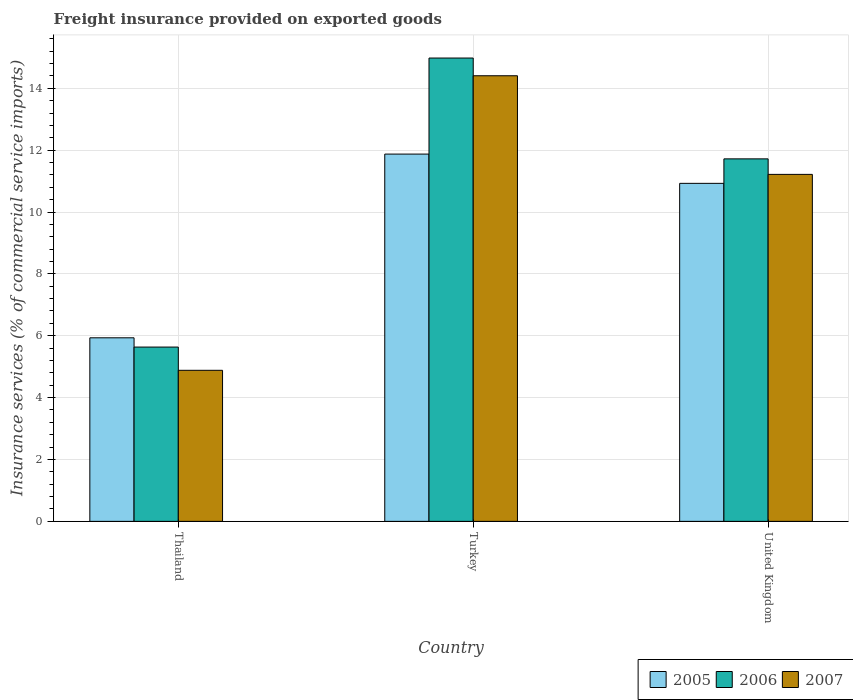How many different coloured bars are there?
Make the answer very short. 3. How many groups of bars are there?
Offer a very short reply. 3. How many bars are there on the 3rd tick from the left?
Your response must be concise. 3. What is the label of the 1st group of bars from the left?
Your answer should be very brief. Thailand. In how many cases, is the number of bars for a given country not equal to the number of legend labels?
Make the answer very short. 0. What is the freight insurance provided on exported goods in 2007 in United Kingdom?
Your answer should be very brief. 11.22. Across all countries, what is the maximum freight insurance provided on exported goods in 2005?
Your answer should be compact. 11.87. Across all countries, what is the minimum freight insurance provided on exported goods in 2005?
Your response must be concise. 5.93. In which country was the freight insurance provided on exported goods in 2005 minimum?
Give a very brief answer. Thailand. What is the total freight insurance provided on exported goods in 2007 in the graph?
Keep it short and to the point. 30.5. What is the difference between the freight insurance provided on exported goods in 2007 in Thailand and that in United Kingdom?
Keep it short and to the point. -6.33. What is the difference between the freight insurance provided on exported goods in 2005 in Thailand and the freight insurance provided on exported goods in 2007 in Turkey?
Offer a terse response. -8.47. What is the average freight insurance provided on exported goods in 2006 per country?
Offer a very short reply. 10.78. What is the difference between the freight insurance provided on exported goods of/in 2007 and freight insurance provided on exported goods of/in 2005 in Thailand?
Give a very brief answer. -1.05. What is the ratio of the freight insurance provided on exported goods in 2005 in Thailand to that in United Kingdom?
Provide a short and direct response. 0.54. Is the freight insurance provided on exported goods in 2006 in Thailand less than that in United Kingdom?
Offer a very short reply. Yes. Is the difference between the freight insurance provided on exported goods in 2007 in Turkey and United Kingdom greater than the difference between the freight insurance provided on exported goods in 2005 in Turkey and United Kingdom?
Your answer should be compact. Yes. What is the difference between the highest and the second highest freight insurance provided on exported goods in 2006?
Provide a short and direct response. 6.08. What is the difference between the highest and the lowest freight insurance provided on exported goods in 2006?
Your response must be concise. 9.34. In how many countries, is the freight insurance provided on exported goods in 2005 greater than the average freight insurance provided on exported goods in 2005 taken over all countries?
Keep it short and to the point. 2. Is the sum of the freight insurance provided on exported goods in 2005 in Thailand and Turkey greater than the maximum freight insurance provided on exported goods in 2006 across all countries?
Your response must be concise. Yes. What does the 2nd bar from the left in Turkey represents?
Your answer should be very brief. 2006. What does the 3rd bar from the right in Turkey represents?
Give a very brief answer. 2005. Are all the bars in the graph horizontal?
Give a very brief answer. No. How many countries are there in the graph?
Keep it short and to the point. 3. What is the difference between two consecutive major ticks on the Y-axis?
Make the answer very short. 2. Are the values on the major ticks of Y-axis written in scientific E-notation?
Your response must be concise. No. Where does the legend appear in the graph?
Make the answer very short. Bottom right. How many legend labels are there?
Give a very brief answer. 3. How are the legend labels stacked?
Your answer should be very brief. Horizontal. What is the title of the graph?
Provide a succinct answer. Freight insurance provided on exported goods. What is the label or title of the X-axis?
Your answer should be very brief. Country. What is the label or title of the Y-axis?
Ensure brevity in your answer.  Insurance services (% of commercial service imports). What is the Insurance services (% of commercial service imports) in 2005 in Thailand?
Provide a short and direct response. 5.93. What is the Insurance services (% of commercial service imports) of 2006 in Thailand?
Your response must be concise. 5.63. What is the Insurance services (% of commercial service imports) of 2007 in Thailand?
Offer a terse response. 4.88. What is the Insurance services (% of commercial service imports) in 2005 in Turkey?
Keep it short and to the point. 11.87. What is the Insurance services (% of commercial service imports) of 2006 in Turkey?
Your response must be concise. 14.98. What is the Insurance services (% of commercial service imports) in 2007 in Turkey?
Provide a short and direct response. 14.4. What is the Insurance services (% of commercial service imports) of 2005 in United Kingdom?
Offer a terse response. 10.93. What is the Insurance services (% of commercial service imports) of 2006 in United Kingdom?
Keep it short and to the point. 11.72. What is the Insurance services (% of commercial service imports) of 2007 in United Kingdom?
Make the answer very short. 11.22. Across all countries, what is the maximum Insurance services (% of commercial service imports) in 2005?
Provide a short and direct response. 11.87. Across all countries, what is the maximum Insurance services (% of commercial service imports) of 2006?
Ensure brevity in your answer.  14.98. Across all countries, what is the maximum Insurance services (% of commercial service imports) in 2007?
Your answer should be very brief. 14.4. Across all countries, what is the minimum Insurance services (% of commercial service imports) of 2005?
Provide a short and direct response. 5.93. Across all countries, what is the minimum Insurance services (% of commercial service imports) in 2006?
Keep it short and to the point. 5.63. Across all countries, what is the minimum Insurance services (% of commercial service imports) of 2007?
Your response must be concise. 4.88. What is the total Insurance services (% of commercial service imports) of 2005 in the graph?
Keep it short and to the point. 28.73. What is the total Insurance services (% of commercial service imports) of 2006 in the graph?
Offer a very short reply. 32.33. What is the total Insurance services (% of commercial service imports) of 2007 in the graph?
Offer a very short reply. 30.5. What is the difference between the Insurance services (% of commercial service imports) in 2005 in Thailand and that in Turkey?
Your answer should be compact. -5.94. What is the difference between the Insurance services (% of commercial service imports) in 2006 in Thailand and that in Turkey?
Your response must be concise. -9.34. What is the difference between the Insurance services (% of commercial service imports) of 2007 in Thailand and that in Turkey?
Provide a short and direct response. -9.52. What is the difference between the Insurance services (% of commercial service imports) of 2005 in Thailand and that in United Kingdom?
Provide a short and direct response. -4.99. What is the difference between the Insurance services (% of commercial service imports) in 2006 in Thailand and that in United Kingdom?
Give a very brief answer. -6.08. What is the difference between the Insurance services (% of commercial service imports) of 2007 in Thailand and that in United Kingdom?
Provide a succinct answer. -6.33. What is the difference between the Insurance services (% of commercial service imports) of 2005 in Turkey and that in United Kingdom?
Offer a terse response. 0.95. What is the difference between the Insurance services (% of commercial service imports) of 2006 in Turkey and that in United Kingdom?
Provide a short and direct response. 3.26. What is the difference between the Insurance services (% of commercial service imports) of 2007 in Turkey and that in United Kingdom?
Offer a very short reply. 3.19. What is the difference between the Insurance services (% of commercial service imports) in 2005 in Thailand and the Insurance services (% of commercial service imports) in 2006 in Turkey?
Provide a short and direct response. -9.04. What is the difference between the Insurance services (% of commercial service imports) of 2005 in Thailand and the Insurance services (% of commercial service imports) of 2007 in Turkey?
Offer a very short reply. -8.47. What is the difference between the Insurance services (% of commercial service imports) in 2006 in Thailand and the Insurance services (% of commercial service imports) in 2007 in Turkey?
Give a very brief answer. -8.77. What is the difference between the Insurance services (% of commercial service imports) in 2005 in Thailand and the Insurance services (% of commercial service imports) in 2006 in United Kingdom?
Make the answer very short. -5.78. What is the difference between the Insurance services (% of commercial service imports) of 2005 in Thailand and the Insurance services (% of commercial service imports) of 2007 in United Kingdom?
Your response must be concise. -5.28. What is the difference between the Insurance services (% of commercial service imports) in 2006 in Thailand and the Insurance services (% of commercial service imports) in 2007 in United Kingdom?
Your answer should be compact. -5.58. What is the difference between the Insurance services (% of commercial service imports) in 2005 in Turkey and the Insurance services (% of commercial service imports) in 2006 in United Kingdom?
Provide a succinct answer. 0.15. What is the difference between the Insurance services (% of commercial service imports) of 2005 in Turkey and the Insurance services (% of commercial service imports) of 2007 in United Kingdom?
Ensure brevity in your answer.  0.66. What is the difference between the Insurance services (% of commercial service imports) in 2006 in Turkey and the Insurance services (% of commercial service imports) in 2007 in United Kingdom?
Provide a short and direct response. 3.76. What is the average Insurance services (% of commercial service imports) of 2005 per country?
Offer a very short reply. 9.58. What is the average Insurance services (% of commercial service imports) of 2006 per country?
Your answer should be compact. 10.78. What is the average Insurance services (% of commercial service imports) of 2007 per country?
Offer a terse response. 10.17. What is the difference between the Insurance services (% of commercial service imports) of 2005 and Insurance services (% of commercial service imports) of 2006 in Thailand?
Ensure brevity in your answer.  0.3. What is the difference between the Insurance services (% of commercial service imports) of 2005 and Insurance services (% of commercial service imports) of 2007 in Thailand?
Your response must be concise. 1.05. What is the difference between the Insurance services (% of commercial service imports) of 2006 and Insurance services (% of commercial service imports) of 2007 in Thailand?
Give a very brief answer. 0.75. What is the difference between the Insurance services (% of commercial service imports) of 2005 and Insurance services (% of commercial service imports) of 2006 in Turkey?
Ensure brevity in your answer.  -3.1. What is the difference between the Insurance services (% of commercial service imports) in 2005 and Insurance services (% of commercial service imports) in 2007 in Turkey?
Keep it short and to the point. -2.53. What is the difference between the Insurance services (% of commercial service imports) of 2006 and Insurance services (% of commercial service imports) of 2007 in Turkey?
Provide a succinct answer. 0.57. What is the difference between the Insurance services (% of commercial service imports) of 2005 and Insurance services (% of commercial service imports) of 2006 in United Kingdom?
Keep it short and to the point. -0.79. What is the difference between the Insurance services (% of commercial service imports) of 2005 and Insurance services (% of commercial service imports) of 2007 in United Kingdom?
Keep it short and to the point. -0.29. What is the difference between the Insurance services (% of commercial service imports) of 2006 and Insurance services (% of commercial service imports) of 2007 in United Kingdom?
Ensure brevity in your answer.  0.5. What is the ratio of the Insurance services (% of commercial service imports) of 2005 in Thailand to that in Turkey?
Keep it short and to the point. 0.5. What is the ratio of the Insurance services (% of commercial service imports) of 2006 in Thailand to that in Turkey?
Keep it short and to the point. 0.38. What is the ratio of the Insurance services (% of commercial service imports) in 2007 in Thailand to that in Turkey?
Offer a terse response. 0.34. What is the ratio of the Insurance services (% of commercial service imports) in 2005 in Thailand to that in United Kingdom?
Provide a short and direct response. 0.54. What is the ratio of the Insurance services (% of commercial service imports) of 2006 in Thailand to that in United Kingdom?
Make the answer very short. 0.48. What is the ratio of the Insurance services (% of commercial service imports) of 2007 in Thailand to that in United Kingdom?
Provide a short and direct response. 0.44. What is the ratio of the Insurance services (% of commercial service imports) in 2005 in Turkey to that in United Kingdom?
Keep it short and to the point. 1.09. What is the ratio of the Insurance services (% of commercial service imports) in 2006 in Turkey to that in United Kingdom?
Ensure brevity in your answer.  1.28. What is the ratio of the Insurance services (% of commercial service imports) of 2007 in Turkey to that in United Kingdom?
Your answer should be compact. 1.28. What is the difference between the highest and the second highest Insurance services (% of commercial service imports) in 2005?
Your answer should be compact. 0.95. What is the difference between the highest and the second highest Insurance services (% of commercial service imports) in 2006?
Ensure brevity in your answer.  3.26. What is the difference between the highest and the second highest Insurance services (% of commercial service imports) in 2007?
Provide a succinct answer. 3.19. What is the difference between the highest and the lowest Insurance services (% of commercial service imports) in 2005?
Ensure brevity in your answer.  5.94. What is the difference between the highest and the lowest Insurance services (% of commercial service imports) in 2006?
Your answer should be compact. 9.34. What is the difference between the highest and the lowest Insurance services (% of commercial service imports) of 2007?
Make the answer very short. 9.52. 